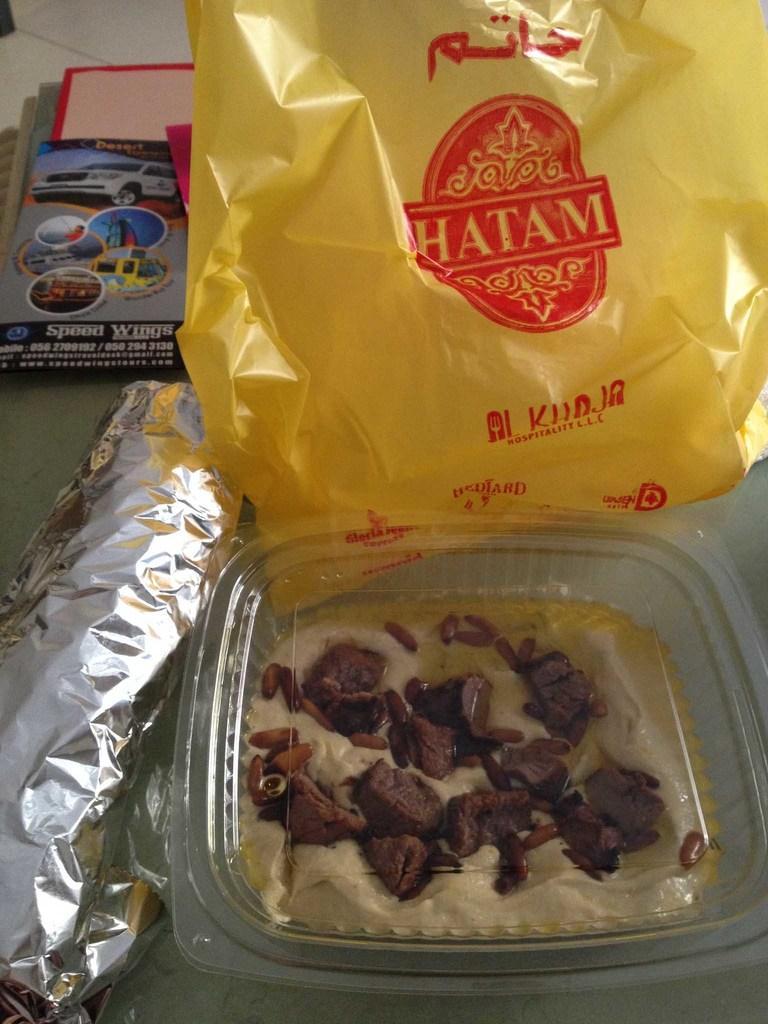Describe this image in one or two sentences. In this image I can see food which is in brown and cream color in the plastic bowl. Background I can see a cover in yellow color and few papers on some surface. 